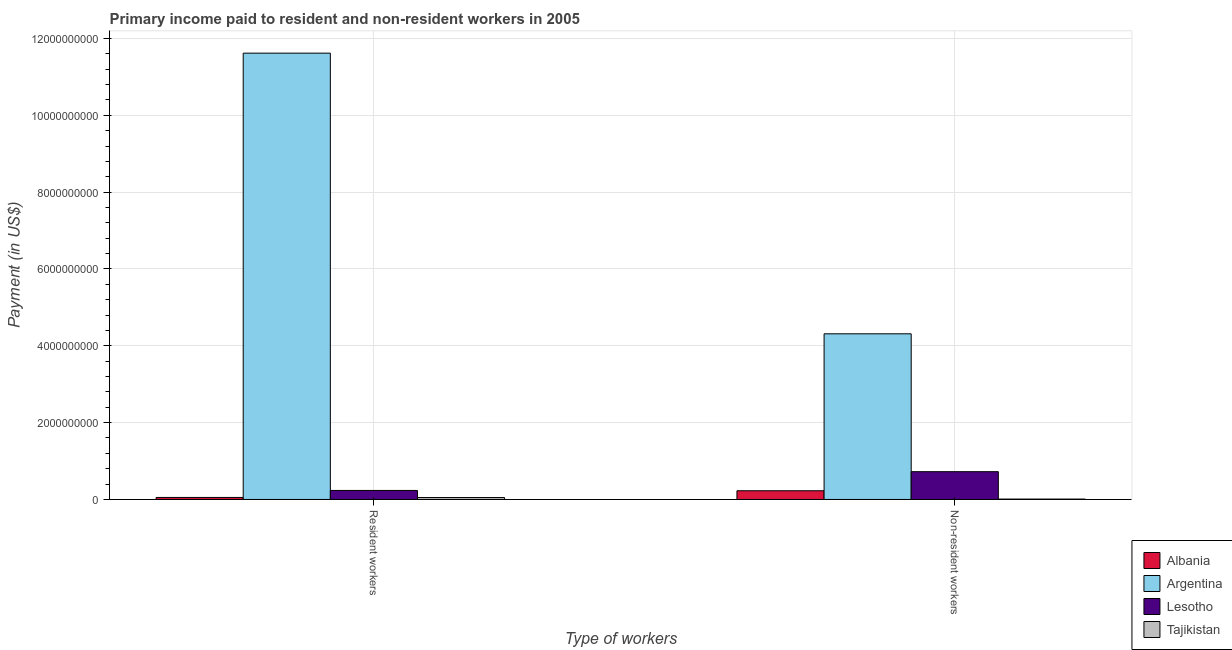How many bars are there on the 2nd tick from the right?
Provide a short and direct response. 4. What is the label of the 1st group of bars from the left?
Keep it short and to the point. Resident workers. What is the payment made to non-resident workers in Lesotho?
Give a very brief answer. 7.23e+08. Across all countries, what is the maximum payment made to non-resident workers?
Offer a terse response. 4.31e+09. Across all countries, what is the minimum payment made to non-resident workers?
Your answer should be compact. 9.59e+06. In which country was the payment made to non-resident workers maximum?
Offer a very short reply. Argentina. In which country was the payment made to non-resident workers minimum?
Provide a succinct answer. Tajikistan. What is the total payment made to non-resident workers in the graph?
Offer a very short reply. 5.27e+09. What is the difference between the payment made to non-resident workers in Tajikistan and that in Lesotho?
Offer a very short reply. -7.14e+08. What is the difference between the payment made to non-resident workers in Lesotho and the payment made to resident workers in Argentina?
Your answer should be very brief. -1.09e+1. What is the average payment made to resident workers per country?
Keep it short and to the point. 2.99e+09. What is the difference between the payment made to resident workers and payment made to non-resident workers in Tajikistan?
Offer a terse response. 4.08e+07. What is the ratio of the payment made to non-resident workers in Argentina to that in Albania?
Your response must be concise. 19.02. What does the 1st bar from the left in Non-resident workers represents?
Your response must be concise. Albania. What does the 3rd bar from the right in Resident workers represents?
Your answer should be very brief. Argentina. How many bars are there?
Your answer should be very brief. 8. Are all the bars in the graph horizontal?
Provide a succinct answer. No. Does the graph contain grids?
Ensure brevity in your answer.  Yes. Where does the legend appear in the graph?
Provide a succinct answer. Bottom right. How many legend labels are there?
Provide a short and direct response. 4. What is the title of the graph?
Offer a terse response. Primary income paid to resident and non-resident workers in 2005. Does "Bermuda" appear as one of the legend labels in the graph?
Your answer should be very brief. No. What is the label or title of the X-axis?
Your answer should be very brief. Type of workers. What is the label or title of the Y-axis?
Your response must be concise. Payment (in US$). What is the Payment (in US$) of Albania in Resident workers?
Your answer should be very brief. 5.26e+07. What is the Payment (in US$) of Argentina in Resident workers?
Provide a succinct answer. 1.16e+1. What is the Payment (in US$) in Lesotho in Resident workers?
Your answer should be very brief. 2.35e+08. What is the Payment (in US$) of Tajikistan in Resident workers?
Your answer should be compact. 5.04e+07. What is the Payment (in US$) in Albania in Non-resident workers?
Your answer should be very brief. 2.27e+08. What is the Payment (in US$) in Argentina in Non-resident workers?
Give a very brief answer. 4.31e+09. What is the Payment (in US$) of Lesotho in Non-resident workers?
Offer a terse response. 7.23e+08. What is the Payment (in US$) in Tajikistan in Non-resident workers?
Your response must be concise. 9.59e+06. Across all Type of workers, what is the maximum Payment (in US$) in Albania?
Provide a succinct answer. 2.27e+08. Across all Type of workers, what is the maximum Payment (in US$) in Argentina?
Keep it short and to the point. 1.16e+1. Across all Type of workers, what is the maximum Payment (in US$) in Lesotho?
Give a very brief answer. 7.23e+08. Across all Type of workers, what is the maximum Payment (in US$) of Tajikistan?
Keep it short and to the point. 5.04e+07. Across all Type of workers, what is the minimum Payment (in US$) of Albania?
Ensure brevity in your answer.  5.26e+07. Across all Type of workers, what is the minimum Payment (in US$) in Argentina?
Provide a succinct answer. 4.31e+09. Across all Type of workers, what is the minimum Payment (in US$) in Lesotho?
Offer a terse response. 2.35e+08. Across all Type of workers, what is the minimum Payment (in US$) of Tajikistan?
Offer a very short reply. 9.59e+06. What is the total Payment (in US$) in Albania in the graph?
Provide a succinct answer. 2.79e+08. What is the total Payment (in US$) in Argentina in the graph?
Keep it short and to the point. 1.59e+1. What is the total Payment (in US$) in Lesotho in the graph?
Provide a short and direct response. 9.58e+08. What is the total Payment (in US$) in Tajikistan in the graph?
Offer a terse response. 5.99e+07. What is the difference between the Payment (in US$) of Albania in Resident workers and that in Non-resident workers?
Your answer should be compact. -1.74e+08. What is the difference between the Payment (in US$) in Argentina in Resident workers and that in Non-resident workers?
Provide a short and direct response. 7.31e+09. What is the difference between the Payment (in US$) of Lesotho in Resident workers and that in Non-resident workers?
Your answer should be compact. -4.88e+08. What is the difference between the Payment (in US$) of Tajikistan in Resident workers and that in Non-resident workers?
Provide a short and direct response. 4.08e+07. What is the difference between the Payment (in US$) in Albania in Resident workers and the Payment (in US$) in Argentina in Non-resident workers?
Your response must be concise. -4.26e+09. What is the difference between the Payment (in US$) in Albania in Resident workers and the Payment (in US$) in Lesotho in Non-resident workers?
Make the answer very short. -6.71e+08. What is the difference between the Payment (in US$) in Albania in Resident workers and the Payment (in US$) in Tajikistan in Non-resident workers?
Offer a very short reply. 4.30e+07. What is the difference between the Payment (in US$) in Argentina in Resident workers and the Payment (in US$) in Lesotho in Non-resident workers?
Give a very brief answer. 1.09e+1. What is the difference between the Payment (in US$) in Argentina in Resident workers and the Payment (in US$) in Tajikistan in Non-resident workers?
Your answer should be compact. 1.16e+1. What is the difference between the Payment (in US$) in Lesotho in Resident workers and the Payment (in US$) in Tajikistan in Non-resident workers?
Give a very brief answer. 2.25e+08. What is the average Payment (in US$) of Albania per Type of workers?
Provide a short and direct response. 1.40e+08. What is the average Payment (in US$) of Argentina per Type of workers?
Make the answer very short. 7.96e+09. What is the average Payment (in US$) in Lesotho per Type of workers?
Provide a succinct answer. 4.79e+08. What is the average Payment (in US$) of Tajikistan per Type of workers?
Your answer should be very brief. 3.00e+07. What is the difference between the Payment (in US$) of Albania and Payment (in US$) of Argentina in Resident workers?
Ensure brevity in your answer.  -1.16e+1. What is the difference between the Payment (in US$) in Albania and Payment (in US$) in Lesotho in Resident workers?
Offer a terse response. -1.82e+08. What is the difference between the Payment (in US$) of Albania and Payment (in US$) of Tajikistan in Resident workers?
Ensure brevity in your answer.  2.25e+06. What is the difference between the Payment (in US$) in Argentina and Payment (in US$) in Lesotho in Resident workers?
Keep it short and to the point. 1.14e+1. What is the difference between the Payment (in US$) of Argentina and Payment (in US$) of Tajikistan in Resident workers?
Ensure brevity in your answer.  1.16e+1. What is the difference between the Payment (in US$) in Lesotho and Payment (in US$) in Tajikistan in Resident workers?
Give a very brief answer. 1.84e+08. What is the difference between the Payment (in US$) of Albania and Payment (in US$) of Argentina in Non-resident workers?
Provide a succinct answer. -4.09e+09. What is the difference between the Payment (in US$) in Albania and Payment (in US$) in Lesotho in Non-resident workers?
Make the answer very short. -4.96e+08. What is the difference between the Payment (in US$) of Albania and Payment (in US$) of Tajikistan in Non-resident workers?
Offer a very short reply. 2.17e+08. What is the difference between the Payment (in US$) in Argentina and Payment (in US$) in Lesotho in Non-resident workers?
Make the answer very short. 3.59e+09. What is the difference between the Payment (in US$) of Argentina and Payment (in US$) of Tajikistan in Non-resident workers?
Keep it short and to the point. 4.30e+09. What is the difference between the Payment (in US$) of Lesotho and Payment (in US$) of Tajikistan in Non-resident workers?
Offer a terse response. 7.14e+08. What is the ratio of the Payment (in US$) in Albania in Resident workers to that in Non-resident workers?
Provide a succinct answer. 0.23. What is the ratio of the Payment (in US$) of Argentina in Resident workers to that in Non-resident workers?
Provide a short and direct response. 2.69. What is the ratio of the Payment (in US$) of Lesotho in Resident workers to that in Non-resident workers?
Give a very brief answer. 0.32. What is the ratio of the Payment (in US$) in Tajikistan in Resident workers to that in Non-resident workers?
Give a very brief answer. 5.25. What is the difference between the highest and the second highest Payment (in US$) in Albania?
Provide a short and direct response. 1.74e+08. What is the difference between the highest and the second highest Payment (in US$) of Argentina?
Provide a short and direct response. 7.31e+09. What is the difference between the highest and the second highest Payment (in US$) in Lesotho?
Provide a succinct answer. 4.88e+08. What is the difference between the highest and the second highest Payment (in US$) in Tajikistan?
Offer a terse response. 4.08e+07. What is the difference between the highest and the lowest Payment (in US$) of Albania?
Keep it short and to the point. 1.74e+08. What is the difference between the highest and the lowest Payment (in US$) in Argentina?
Ensure brevity in your answer.  7.31e+09. What is the difference between the highest and the lowest Payment (in US$) in Lesotho?
Make the answer very short. 4.88e+08. What is the difference between the highest and the lowest Payment (in US$) in Tajikistan?
Provide a succinct answer. 4.08e+07. 